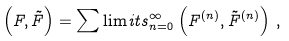<formula> <loc_0><loc_0><loc_500><loc_500>\left ( F , { \tilde { F } } \right ) = \sum \lim i t s _ { n = 0 } ^ { \infty } \left ( F ^ { ( n ) } , { \tilde { F } } ^ { ( n ) } \right ) \, ,</formula> 